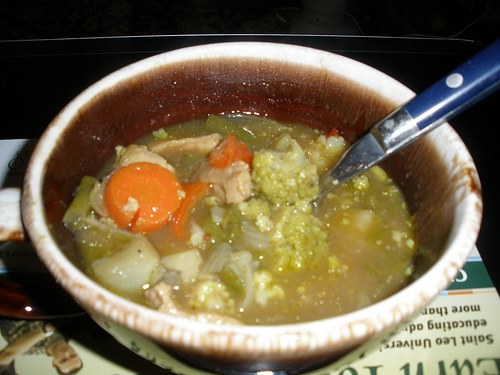Are there bowls to the left of the soup in the bottom of the photo? No, there are no bowls to the left of the soup at the bottom of the photo. 